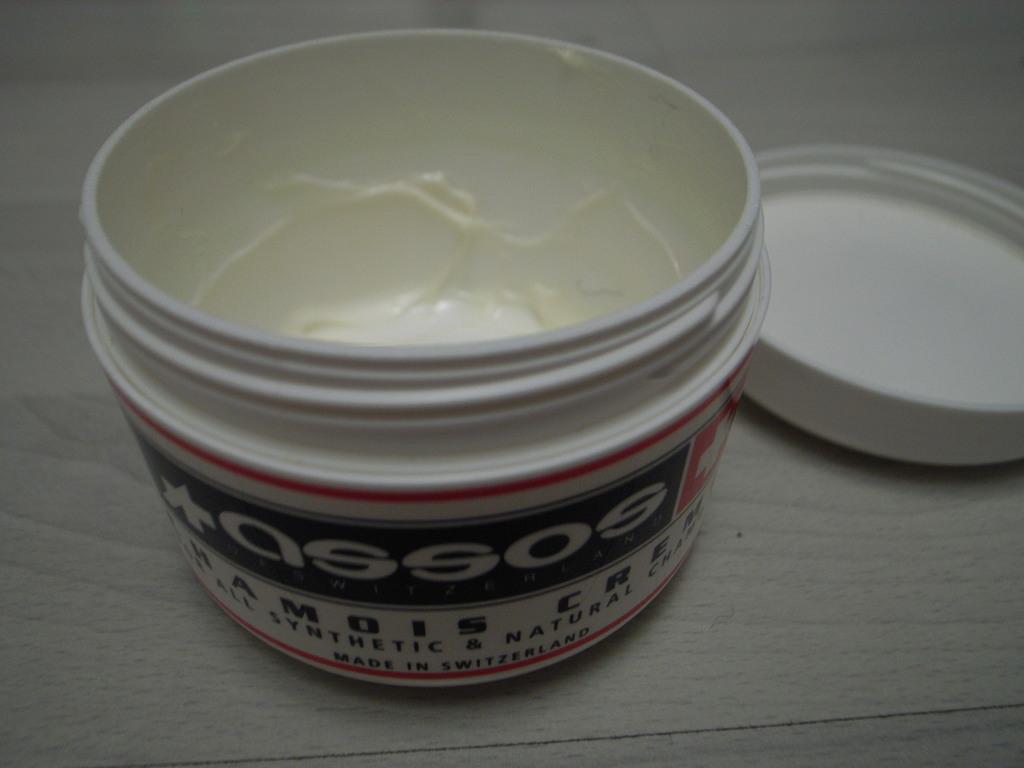Where is the creme made?
Make the answer very short. Switzerland. What brand isi t?
Provide a short and direct response. Assos. 